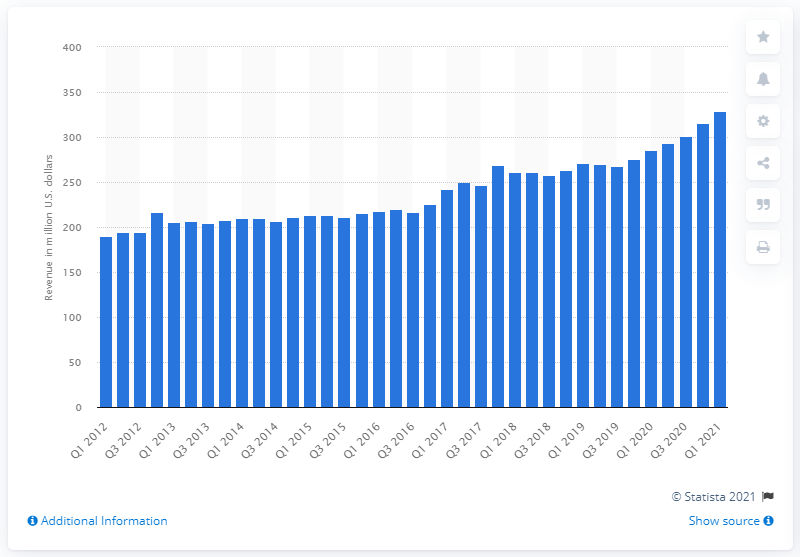Identify some key points in this picture. The circulation revenue of The Times Media Group in the first quarter of 2021 was 285.43. The circulation revenue of The New York Times Media Group in the first quarter of 2021 was 329.08. 